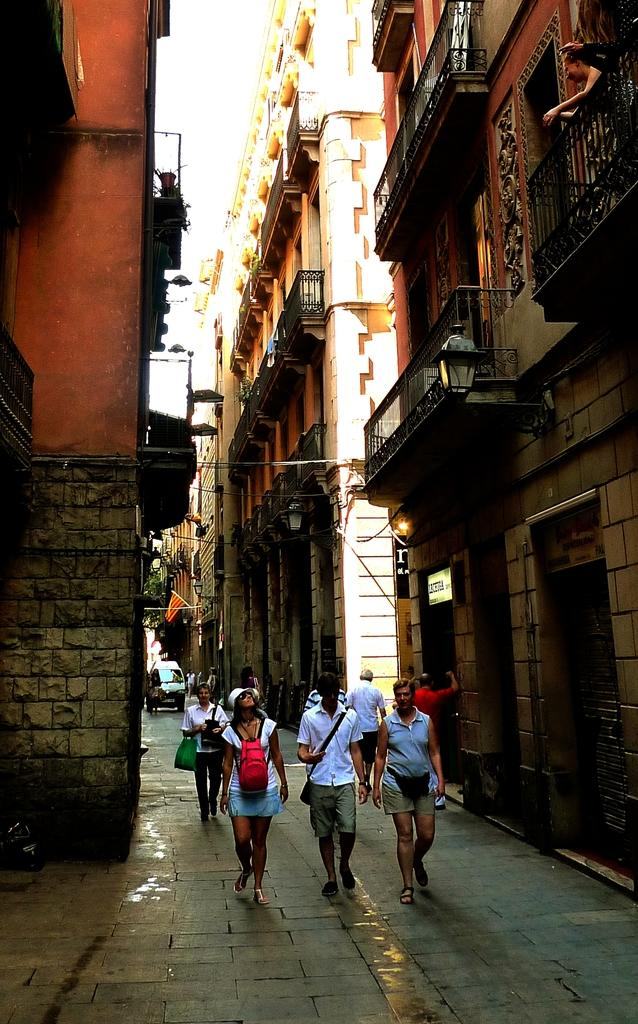What type of structures can be seen in the image? There are buildings in the image. Can you describe the people in the image? There is a group of people in the image. What else is visible in the background of the image? There is a vehicle visible in the background of the image. Where is the light located in the image? There is a light on the right side of the image. What type of soda is being served at the event in the image? There is no event or soda present in the image; it features buildings, a group of people, a vehicle in the background, and a light on the right side. 